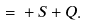Convert formula to latex. <formula><loc_0><loc_0><loc_500><loc_500>\overline { \Gamma } = \Gamma + S + Q .</formula> 